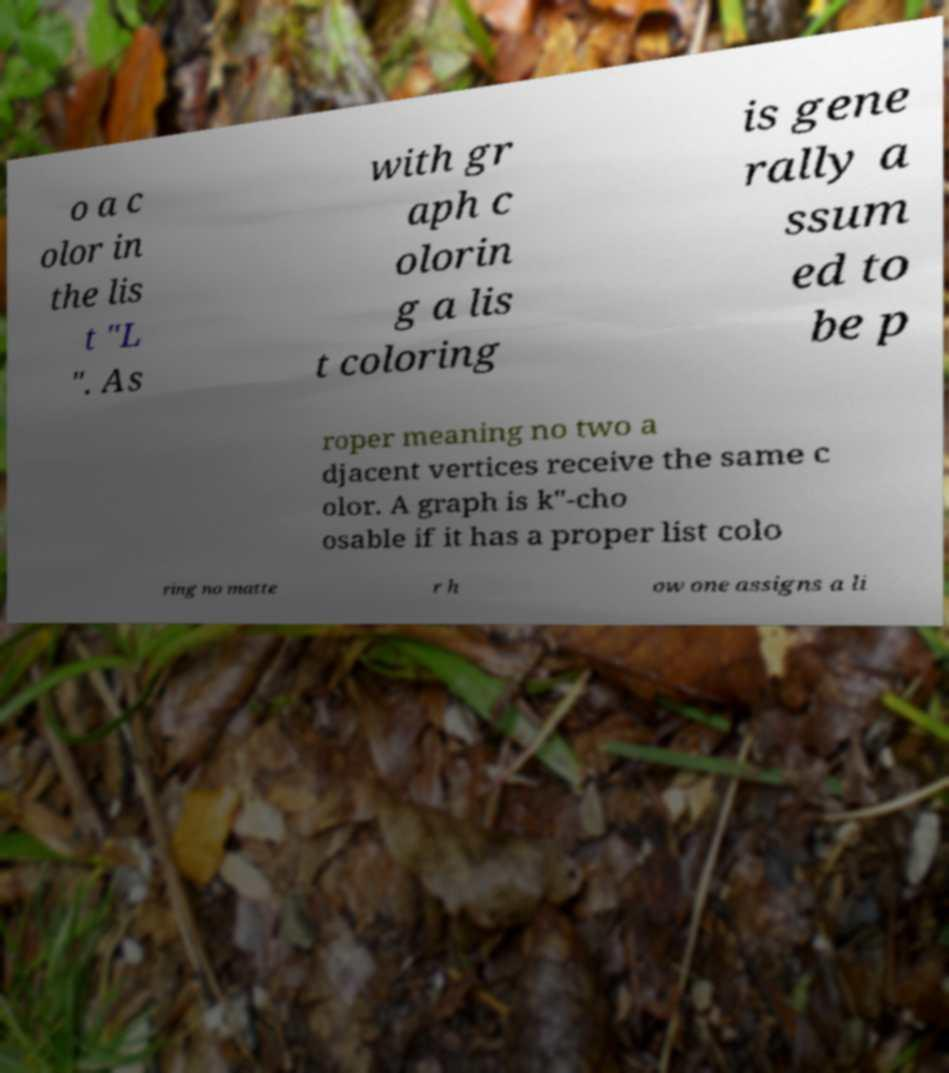Can you accurately transcribe the text from the provided image for me? o a c olor in the lis t "L ". As with gr aph c olorin g a lis t coloring is gene rally a ssum ed to be p roper meaning no two a djacent vertices receive the same c olor. A graph is k"-cho osable if it has a proper list colo ring no matte r h ow one assigns a li 